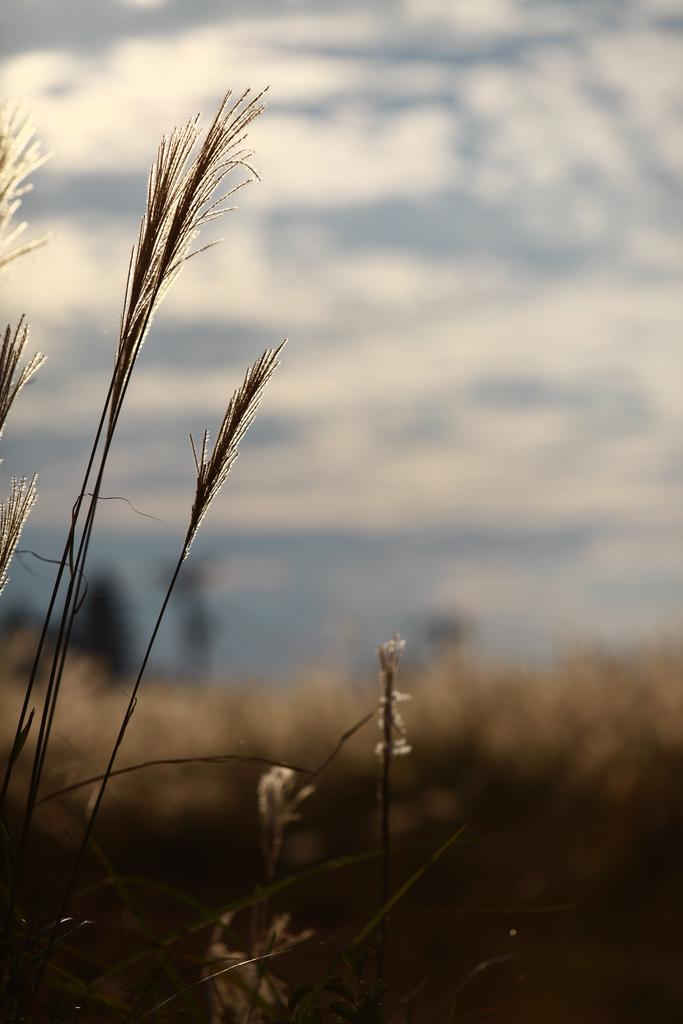What type of vegetation can be seen in the image? There is grass in the image. Can you describe the background of the image? The background of the image is blurred. How much sugar is present in the grass in the image? There is no information about sugar content in the grass in the image. 